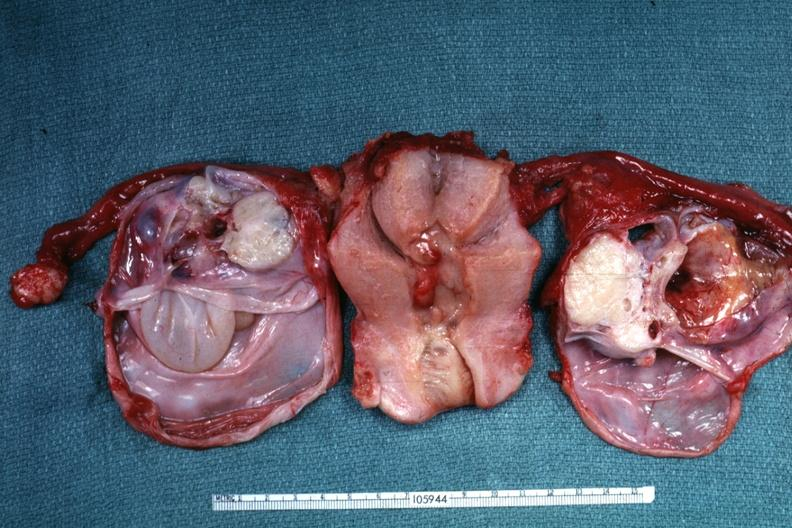s female reproductive present?
Answer the question using a single word or phrase. Yes 